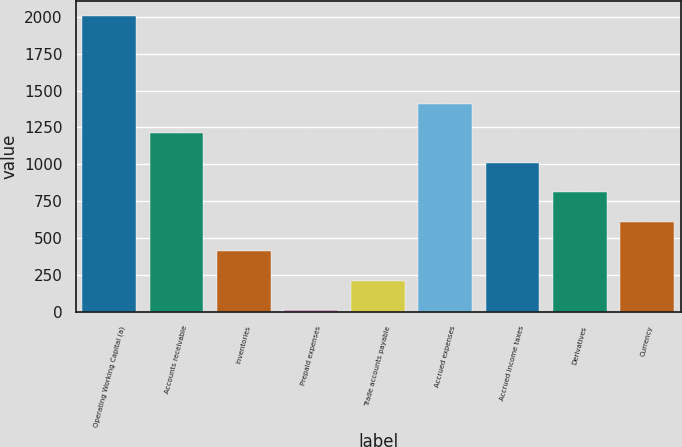<chart> <loc_0><loc_0><loc_500><loc_500><bar_chart><fcel>Operating Working Capital (a)<fcel>Accounts receivable<fcel>Inventories<fcel>Prepaid expenses<fcel>Trade accounts payable<fcel>Accrued expenses<fcel>Accrued income taxes<fcel>Derivatives<fcel>Currency<nl><fcel>2008<fcel>1210<fcel>412<fcel>13<fcel>212.5<fcel>1409.5<fcel>1010.5<fcel>811<fcel>611.5<nl></chart> 